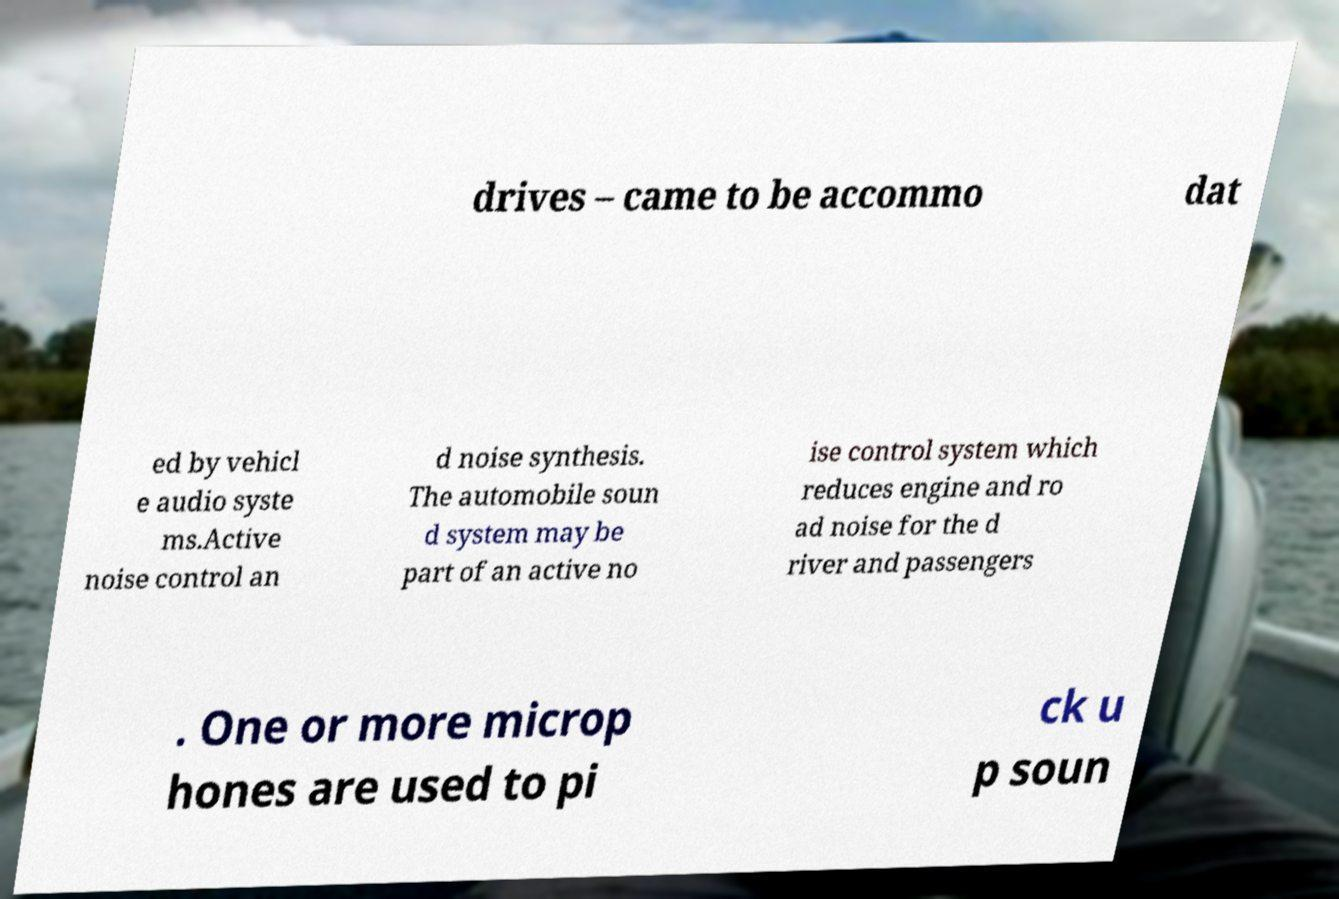Can you accurately transcribe the text from the provided image for me? drives – came to be accommo dat ed by vehicl e audio syste ms.Active noise control an d noise synthesis. The automobile soun d system may be part of an active no ise control system which reduces engine and ro ad noise for the d river and passengers . One or more microp hones are used to pi ck u p soun 